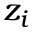Convert formula to latex. <formula><loc_0><loc_0><loc_500><loc_500>z _ { i }</formula> 